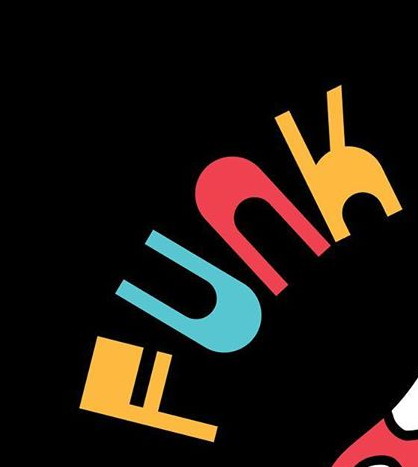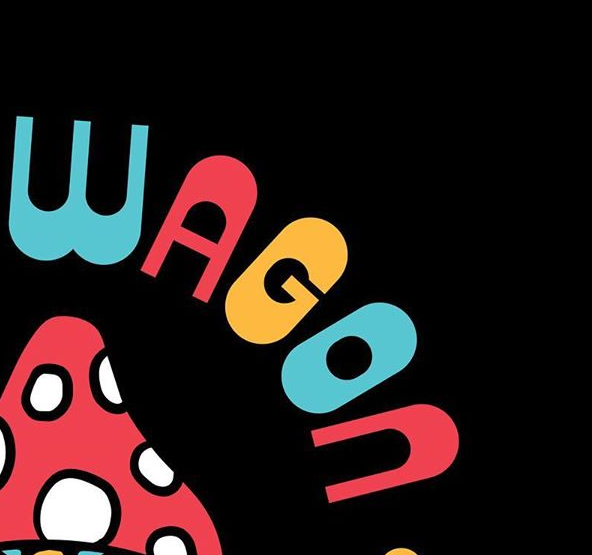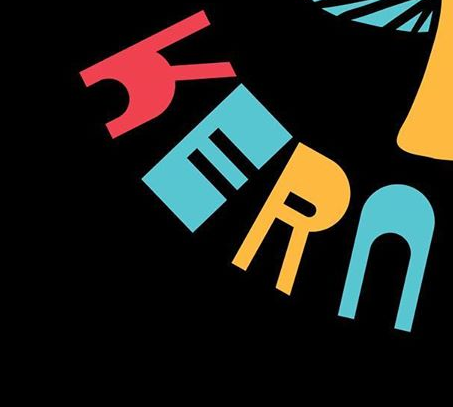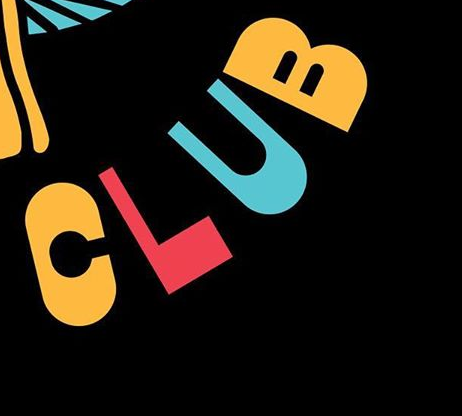What words are shown in these images in order, separated by a semicolon? FUNK; WAGON; KERN; CLUB 